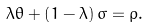Convert formula to latex. <formula><loc_0><loc_0><loc_500><loc_500>\lambda \theta + \left ( 1 - \lambda \right ) \sigma = \rho .</formula> 